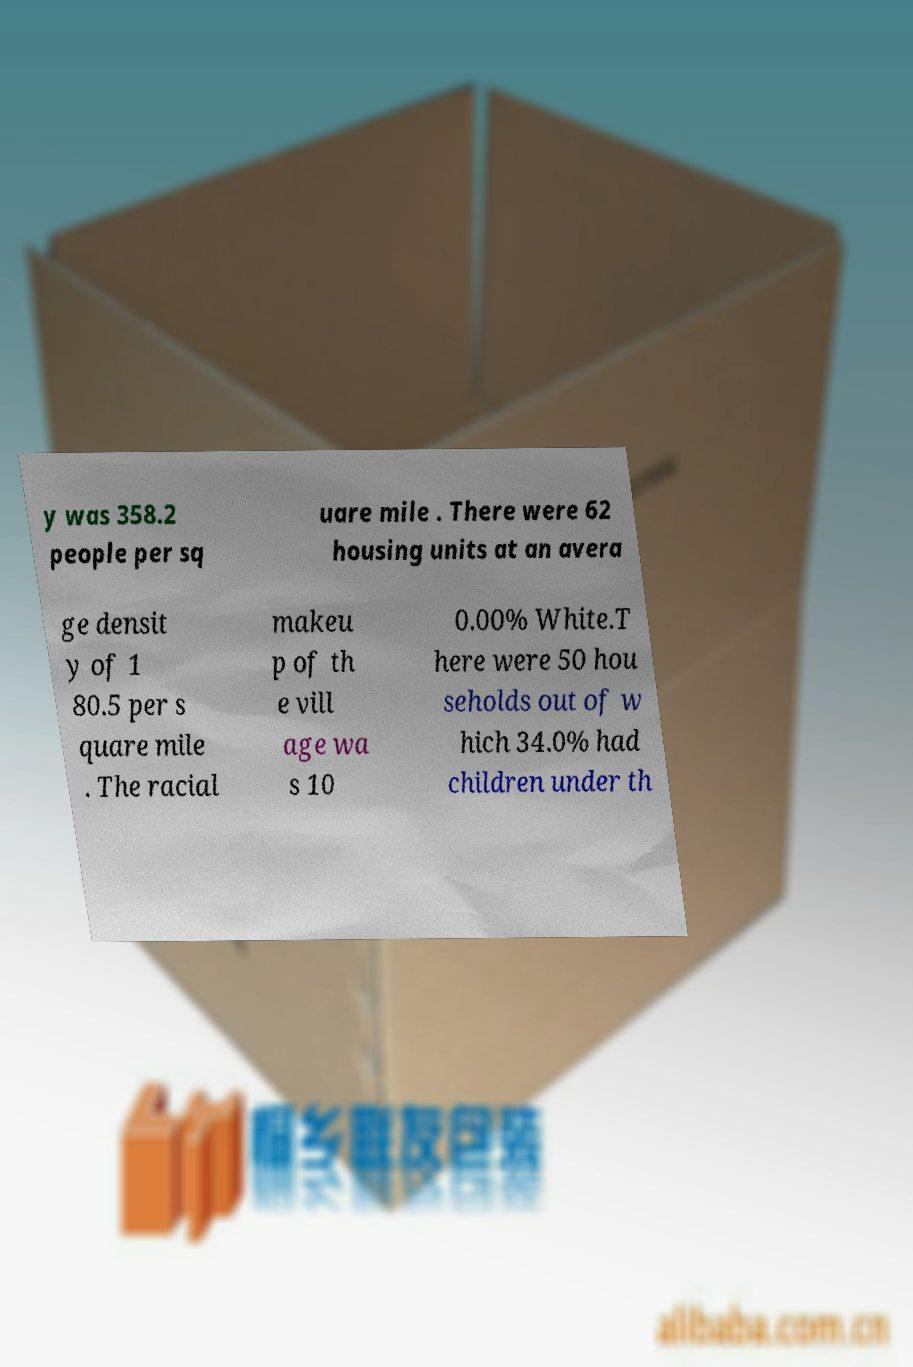For documentation purposes, I need the text within this image transcribed. Could you provide that? y was 358.2 people per sq uare mile . There were 62 housing units at an avera ge densit y of 1 80.5 per s quare mile . The racial makeu p of th e vill age wa s 10 0.00% White.T here were 50 hou seholds out of w hich 34.0% had children under th 